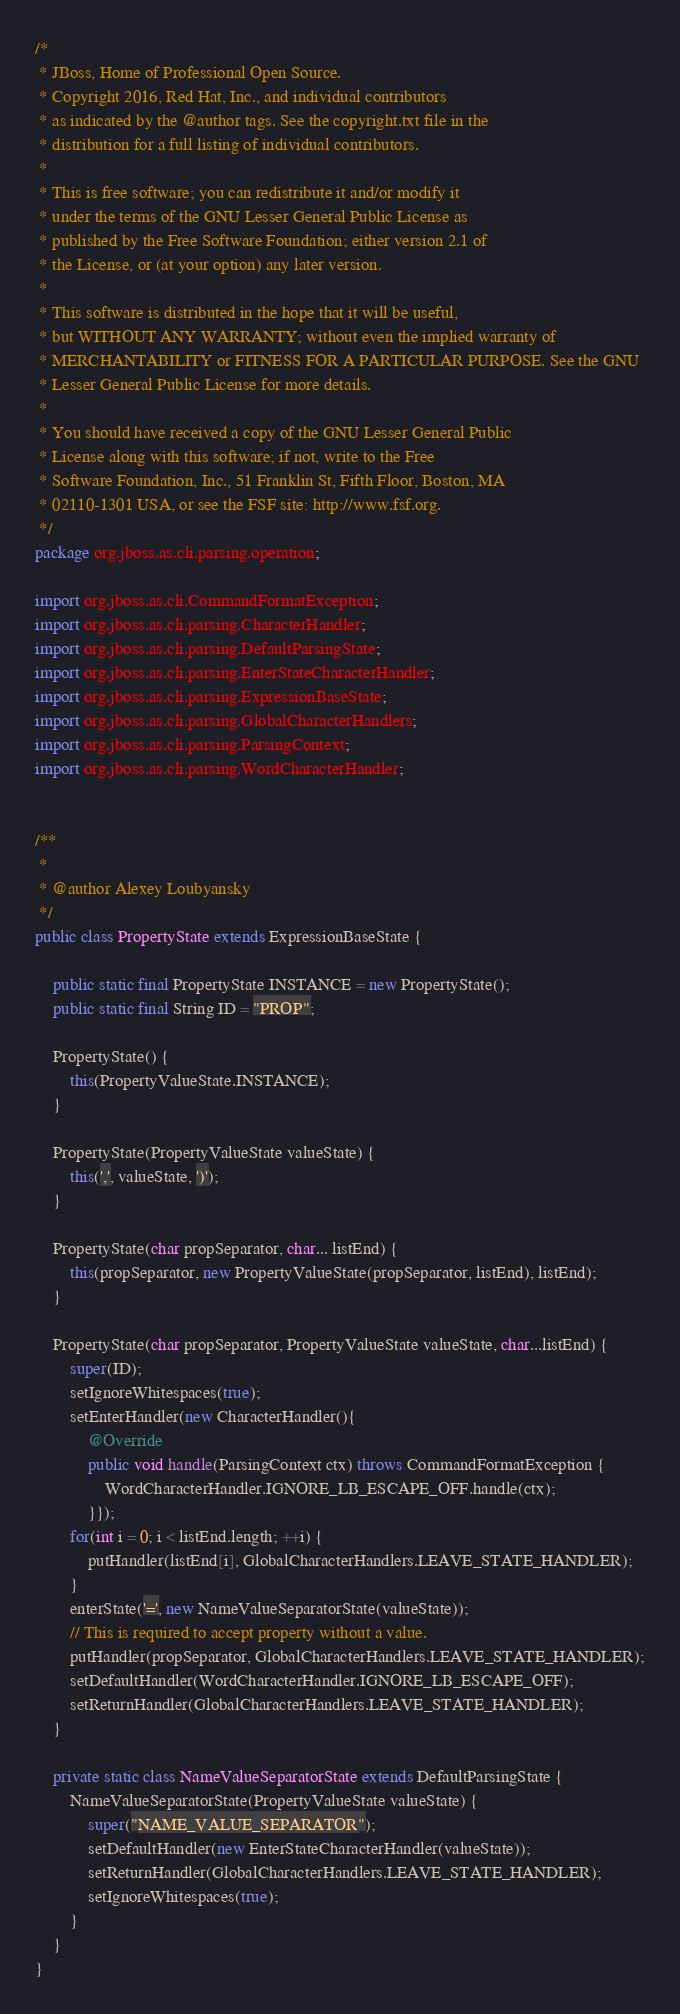Convert code to text. <code><loc_0><loc_0><loc_500><loc_500><_Java_>/*
 * JBoss, Home of Professional Open Source.
 * Copyright 2016, Red Hat, Inc., and individual contributors
 * as indicated by the @author tags. See the copyright.txt file in the
 * distribution for a full listing of individual contributors.
 *
 * This is free software; you can redistribute it and/or modify it
 * under the terms of the GNU Lesser General Public License as
 * published by the Free Software Foundation; either version 2.1 of
 * the License, or (at your option) any later version.
 *
 * This software is distributed in the hope that it will be useful,
 * but WITHOUT ANY WARRANTY; without even the implied warranty of
 * MERCHANTABILITY or FITNESS FOR A PARTICULAR PURPOSE. See the GNU
 * Lesser General Public License for more details.
 *
 * You should have received a copy of the GNU Lesser General Public
 * License along with this software; if not, write to the Free
 * Software Foundation, Inc., 51 Franklin St, Fifth Floor, Boston, MA
 * 02110-1301 USA, or see the FSF site: http://www.fsf.org.
 */
package org.jboss.as.cli.parsing.operation;

import org.jboss.as.cli.CommandFormatException;
import org.jboss.as.cli.parsing.CharacterHandler;
import org.jboss.as.cli.parsing.DefaultParsingState;
import org.jboss.as.cli.parsing.EnterStateCharacterHandler;
import org.jboss.as.cli.parsing.ExpressionBaseState;
import org.jboss.as.cli.parsing.GlobalCharacterHandlers;
import org.jboss.as.cli.parsing.ParsingContext;
import org.jboss.as.cli.parsing.WordCharacterHandler;


/**
 *
 * @author Alexey Loubyansky
 */
public class PropertyState extends ExpressionBaseState {

    public static final PropertyState INSTANCE = new PropertyState();
    public static final String ID = "PROP";

    PropertyState() {
        this(PropertyValueState.INSTANCE);
    }

    PropertyState(PropertyValueState valueState) {
        this(',', valueState, ')');
    }

    PropertyState(char propSeparator, char... listEnd) {
        this(propSeparator, new PropertyValueState(propSeparator, listEnd), listEnd);
    }

    PropertyState(char propSeparator, PropertyValueState valueState, char...listEnd) {
        super(ID);
        setIgnoreWhitespaces(true);
        setEnterHandler(new CharacterHandler(){
            @Override
            public void handle(ParsingContext ctx) throws CommandFormatException {
                WordCharacterHandler.IGNORE_LB_ESCAPE_OFF.handle(ctx);
            }});
        for(int i = 0; i < listEnd.length; ++i) {
            putHandler(listEnd[i], GlobalCharacterHandlers.LEAVE_STATE_HANDLER);
        }
        enterState('=', new NameValueSeparatorState(valueState));
        // This is required to accept property without a value.
        putHandler(propSeparator, GlobalCharacterHandlers.LEAVE_STATE_HANDLER);
        setDefaultHandler(WordCharacterHandler.IGNORE_LB_ESCAPE_OFF);
        setReturnHandler(GlobalCharacterHandlers.LEAVE_STATE_HANDLER);
    }

    private static class NameValueSeparatorState extends DefaultParsingState {
        NameValueSeparatorState(PropertyValueState valueState) {
            super("NAME_VALUE_SEPARATOR");
            setDefaultHandler(new EnterStateCharacterHandler(valueState));
            setReturnHandler(GlobalCharacterHandlers.LEAVE_STATE_HANDLER);
            setIgnoreWhitespaces(true);
        }
    }
}
</code> 